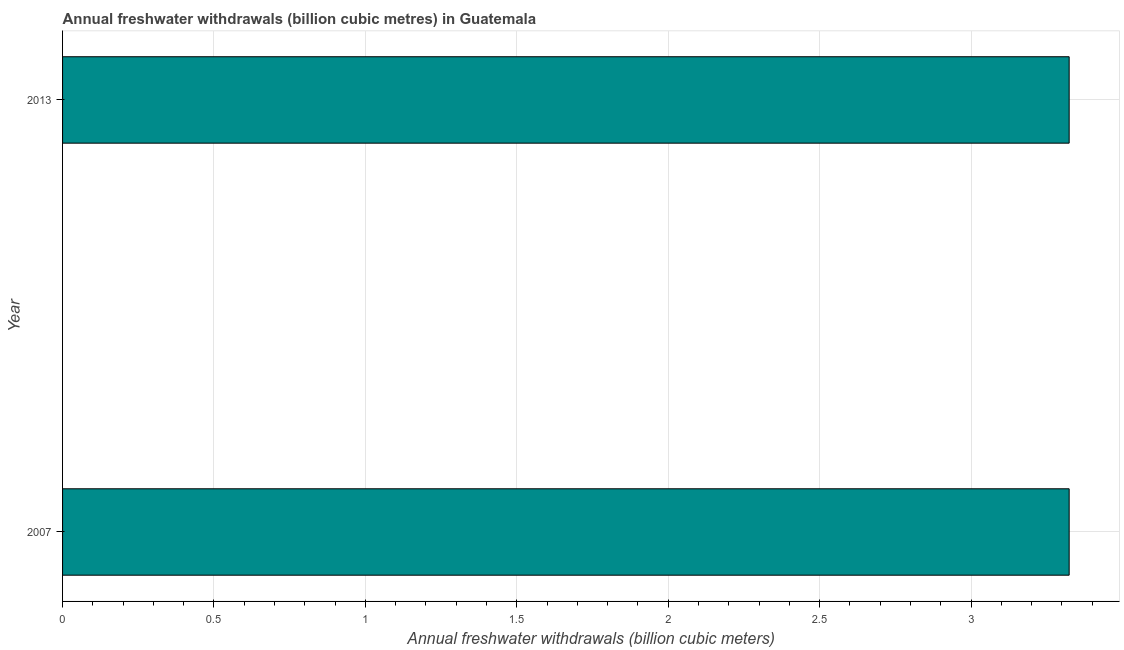Does the graph contain any zero values?
Your answer should be compact. No. Does the graph contain grids?
Provide a short and direct response. Yes. What is the title of the graph?
Keep it short and to the point. Annual freshwater withdrawals (billion cubic metres) in Guatemala. What is the label or title of the X-axis?
Ensure brevity in your answer.  Annual freshwater withdrawals (billion cubic meters). What is the label or title of the Y-axis?
Make the answer very short. Year. What is the annual freshwater withdrawals in 2007?
Make the answer very short. 3.32. Across all years, what is the maximum annual freshwater withdrawals?
Keep it short and to the point. 3.32. Across all years, what is the minimum annual freshwater withdrawals?
Make the answer very short. 3.32. In which year was the annual freshwater withdrawals minimum?
Your answer should be compact. 2007. What is the sum of the annual freshwater withdrawals?
Give a very brief answer. 6.65. What is the difference between the annual freshwater withdrawals in 2007 and 2013?
Make the answer very short. 0. What is the average annual freshwater withdrawals per year?
Your answer should be very brief. 3.32. What is the median annual freshwater withdrawals?
Ensure brevity in your answer.  3.32. In how many years, is the annual freshwater withdrawals greater than 2.2 billion cubic meters?
Keep it short and to the point. 2. What is the ratio of the annual freshwater withdrawals in 2007 to that in 2013?
Make the answer very short. 1. What is the difference between two consecutive major ticks on the X-axis?
Your answer should be very brief. 0.5. Are the values on the major ticks of X-axis written in scientific E-notation?
Your answer should be very brief. No. What is the Annual freshwater withdrawals (billion cubic meters) of 2007?
Keep it short and to the point. 3.32. What is the Annual freshwater withdrawals (billion cubic meters) of 2013?
Your answer should be compact. 3.32. What is the difference between the Annual freshwater withdrawals (billion cubic meters) in 2007 and 2013?
Make the answer very short. 0. What is the ratio of the Annual freshwater withdrawals (billion cubic meters) in 2007 to that in 2013?
Your response must be concise. 1. 